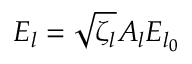<formula> <loc_0><loc_0><loc_500><loc_500>E _ { l } = \sqrt { \zeta _ { l } } A _ { l } E _ { l _ { 0 } }</formula> 